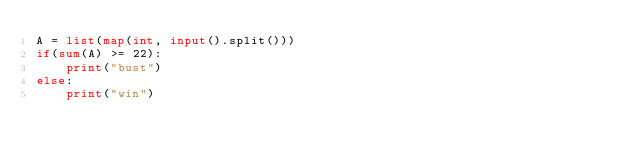<code> <loc_0><loc_0><loc_500><loc_500><_Python_>A = list(map(int, input().split()))
if(sum(A) >= 22):
    print("bust")
else:
    print("win")
</code> 